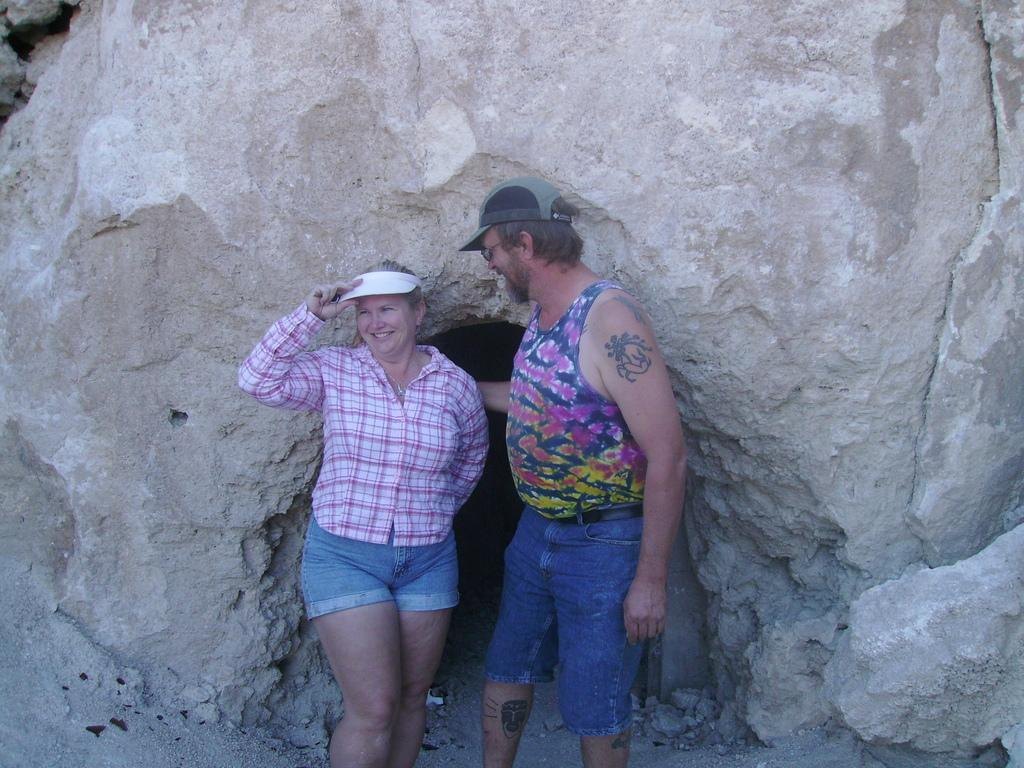How many people are present in the image? There are two people, a man and a woman, present in the image. What are the positions of the man and the woman in the image? Both the man and the woman are standing in the image. What are the man and the woman wearing on their heads? The man and the woman are wearing caps in the image. What can be seen in the background of the image? There is a rock in the background of the image. What type of egg is the man holding in the image? There is no egg present in the image; the man and the woman are both wearing caps. 